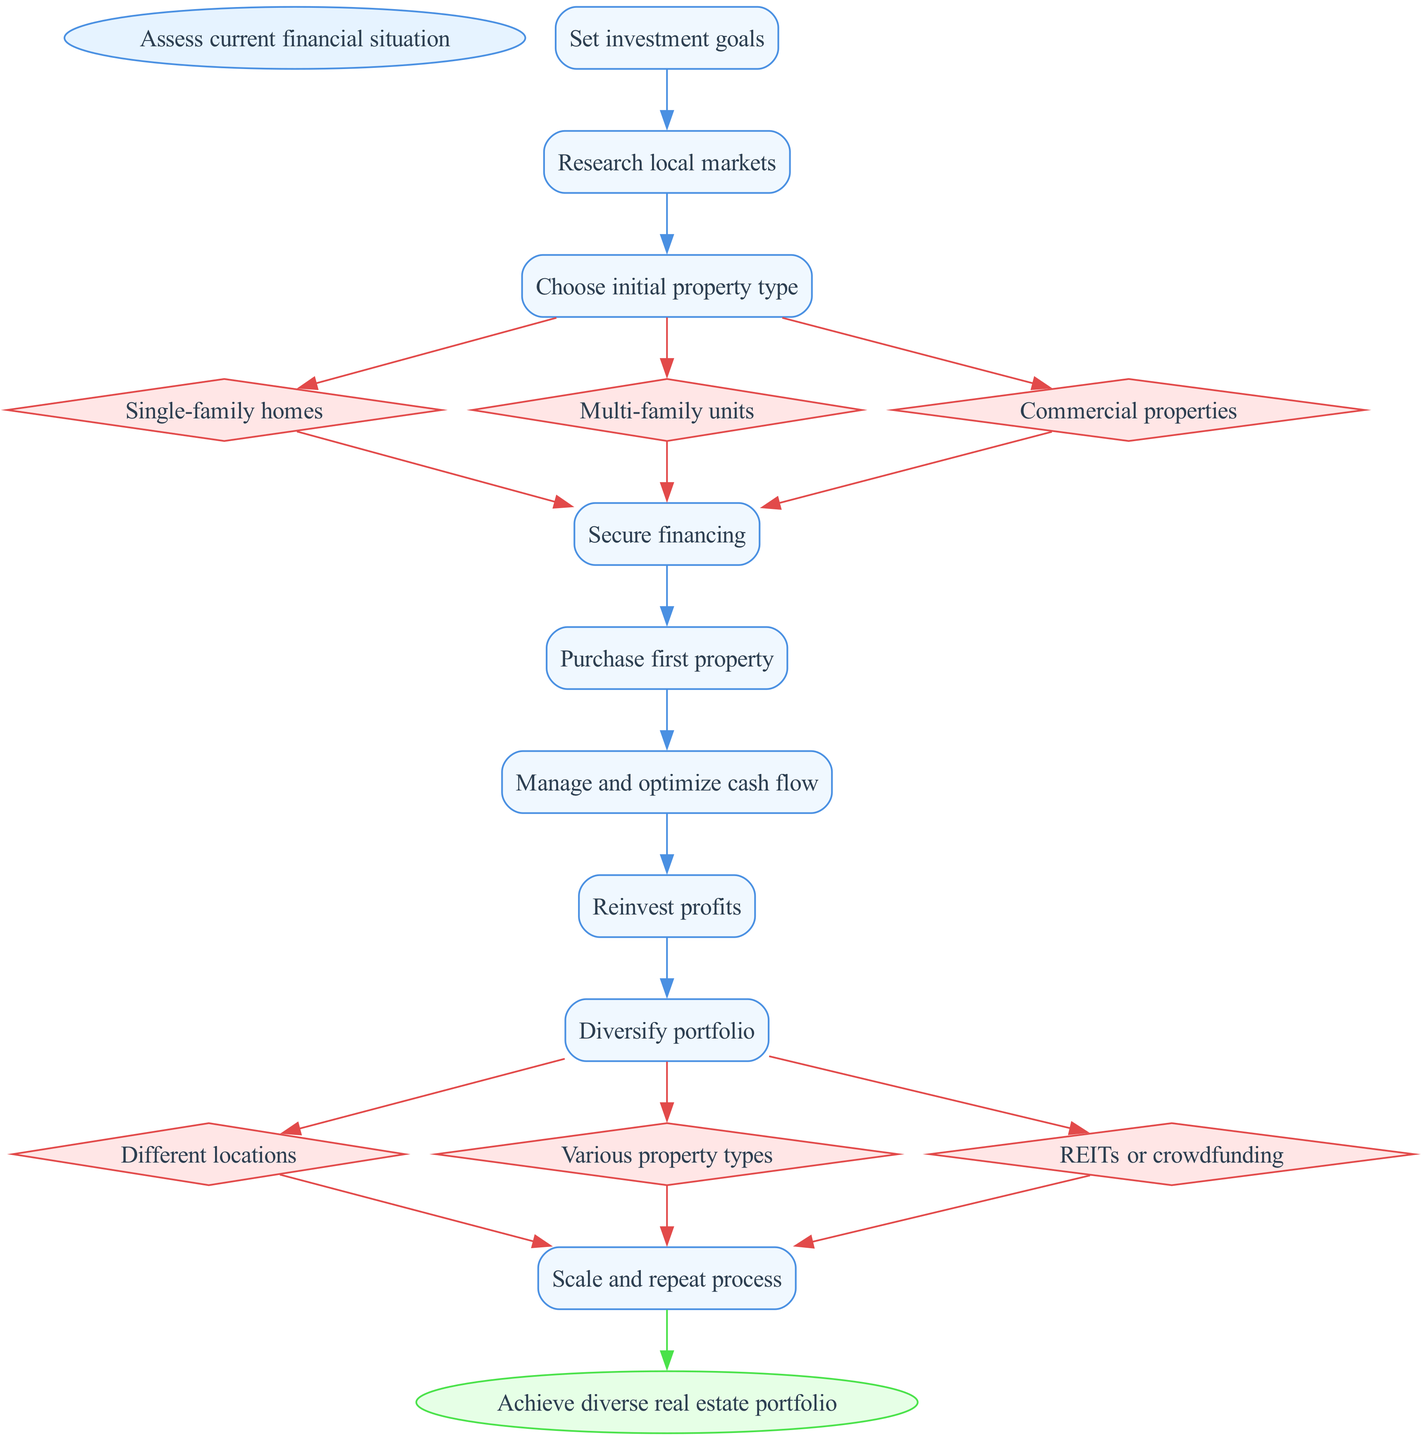What is the starting point of the diagram? The starting point is specified at the beginning of the diagram as "Assess current financial situation."
Answer: Assess current financial situation How many options are available when choosing the initial property type? In the diagram, there are three options available: "Single-family homes," "Multi-family units," and "Commercial properties."
Answer: Three What is the last step before achieving a diverse real estate portfolio? The last step before achieving the final goal is "Scale and repeat process," which is linked directly to the previous step of diversifying the portfolio.
Answer: Scale and repeat process What are the types of diversification mentioned in the diagram? The types of diversification include "Different locations," "Various property types," and "REITs or crowdfunding," which indicate diverse investment strategies.
Answer: Different locations, Various property types, REITs or crowdfunding How many main steps are there in the process outlined in the diagram? The diagram outlines a total of eight main steps from assessing the financial situation to achieving the diverse real estate portfolio.
Answer: Eight 